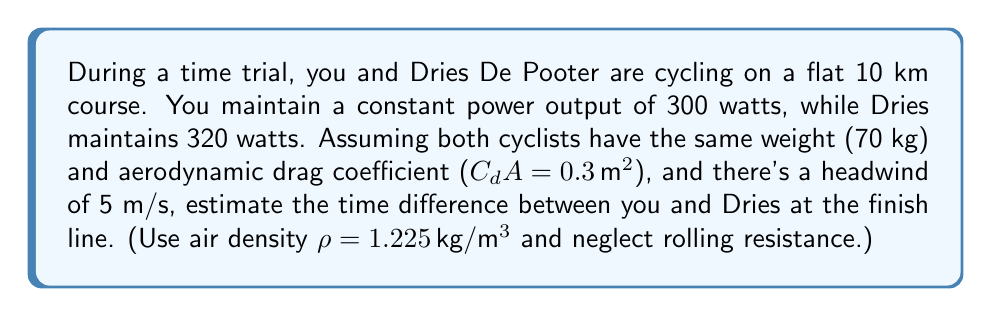Show me your answer to this math problem. To solve this problem, we'll use the following steps:

1) First, we need to calculate the velocity of each cyclist using the power equation:

   $P = F_d v = \frac{1}{2} \rho (v+w)^2 C_d A v$

   Where:
   $P$ is power output (W)
   $F_d$ is drag force (N)
   $v$ is cyclist velocity (m/s)
   $w$ is wind velocity (m/s)
   $\rho$ is air density (kg/m^3)
   $C_d A$ is the product of drag coefficient and frontal area (m^2)

2) Rearranging the equation to solve for $v$:

   $v^3 + 2wv^2 + w^2v - \frac{2P}{\rho C_d A} = 0$

3) This cubic equation can be solved numerically. Using a calculator or computer program, we find:

   For you (300W): $v_1 \approx 9.76$ m/s
   For Dries (320W): $v_2 \approx 10.02$ m/s

4) Now, we can calculate the time each cyclist takes to cover 10 km:

   $t_1 = \frac{10000}{v_1} = \frac{10000}{9.76} \approx 1024.59$ seconds
   $t_2 = \frac{10000}{v_2} = \frac{10000}{10.02} \approx 997.01$ seconds

5) The time difference is:

   $\Delta t = t_1 - t_2 = 1024.59 - 997.01 \approx 27.58$ seconds

Therefore, Dries will finish approximately 27.58 seconds ahead of you.
Answer: The time difference at the finish line is approximately 27.58 seconds, with Dries De Pooter finishing ahead. 